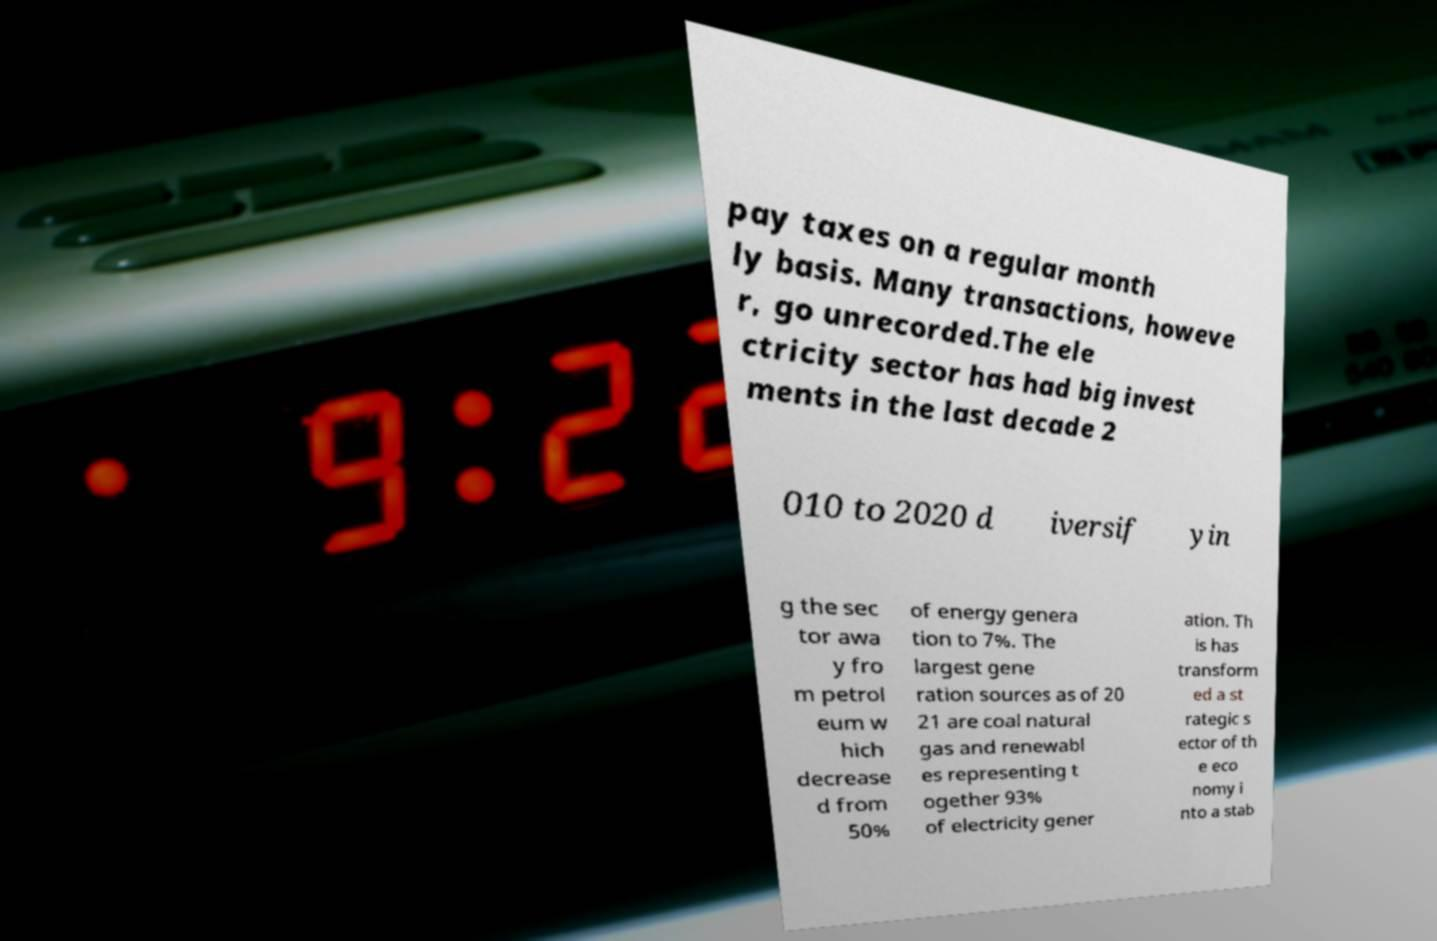Please read and relay the text visible in this image. What does it say? pay taxes on a regular month ly basis. Many transactions, howeve r, go unrecorded.The ele ctricity sector has had big invest ments in the last decade 2 010 to 2020 d iversif yin g the sec tor awa y fro m petrol eum w hich decrease d from 50% of energy genera tion to 7%. The largest gene ration sources as of 20 21 are coal natural gas and renewabl es representing t ogether 93% of electricity gener ation. Th is has transform ed a st rategic s ector of th e eco nomy i nto a stab 